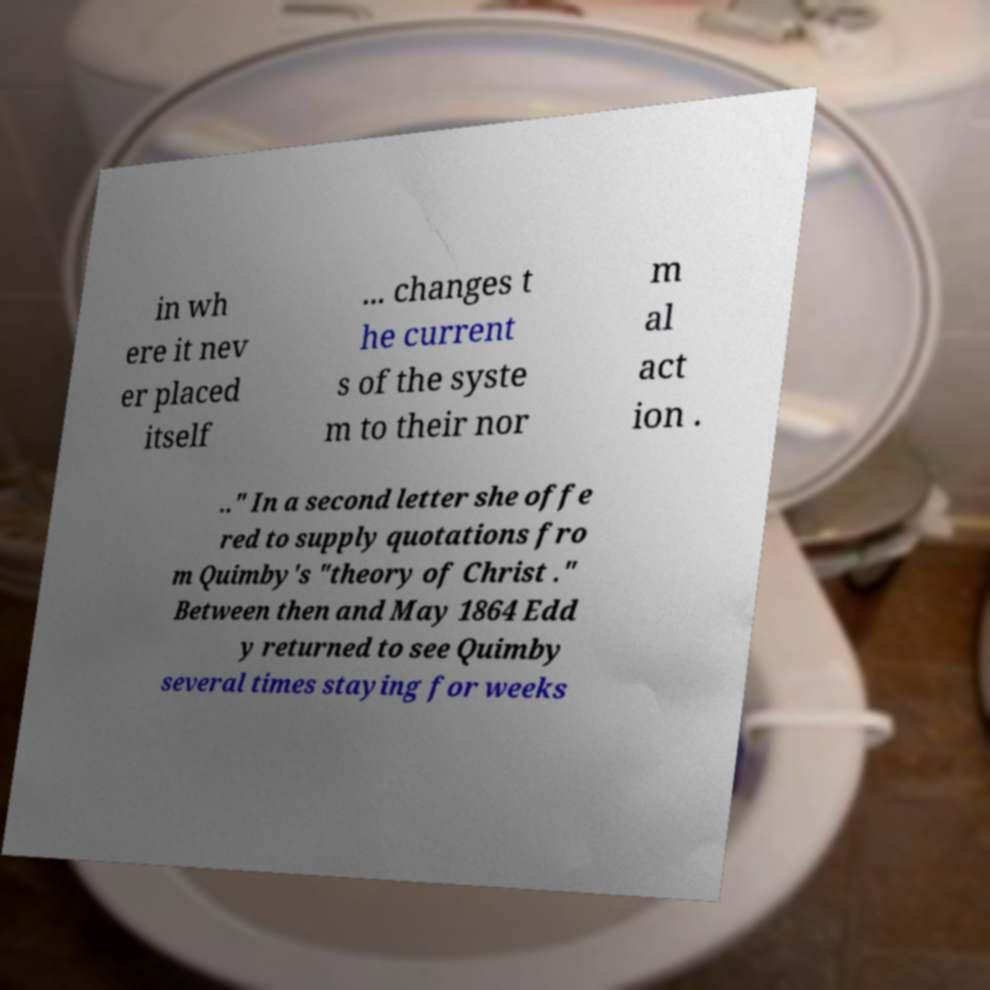Please identify and transcribe the text found in this image. in wh ere it nev er placed itself ... changes t he current s of the syste m to their nor m al act ion . .." In a second letter she offe red to supply quotations fro m Quimby's "theory of Christ ." Between then and May 1864 Edd y returned to see Quimby several times staying for weeks 